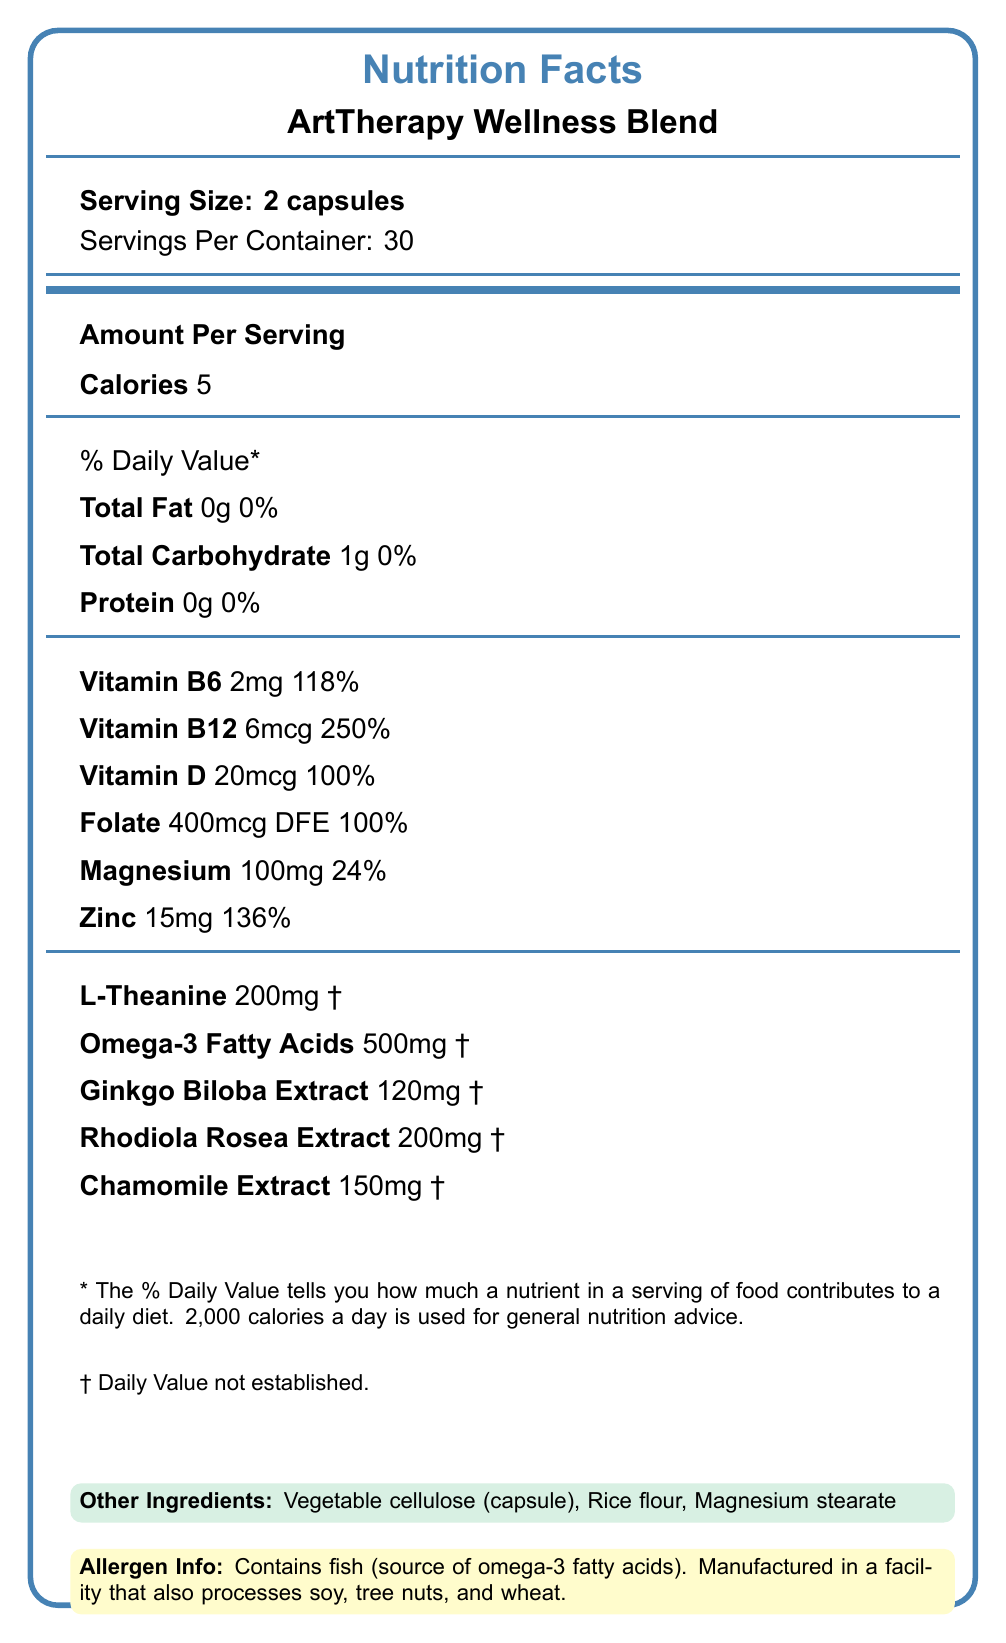what is the serving size of the product? The serving size is clearly mentioned as "Serving Size: 2 capsules" in the document.
Answer: 2 capsules how many servings are there per container? The document states "Servings Per Container: 30".
Answer: 30 what is the calorie content per serving? The document lists the amount per serving, specifying "Calories 5".
Answer: 5 calories what is the amount of Vitamin D per serving? The document specifies "Vitamin D 20mcg".
Answer: 20mcg name two other ingredients included in the capsules. The section labeled "Other Ingredients" includes "Vegetable cellulose (capsule)" and "Rice flour" among others.
Answer: Vegetable cellulose (capsule), Rice flour does this product contain any allergens? According to the document, the product contains fish as an allergen.
Answer: Yes summarize the main benefits of this product. The "Benefits" section lists four key areas where the product claims to offer advantages.
Answer: Supports cognitive function and creativity, promotes relaxation and stress reduction, enhances mood and emotional well-being, aids in focus and concentration during art therapy sessions. what is the amount of Omega-3 Fatty Acids per serving? The document specifies "Omega-3 Fatty Acids 500mg".
Answer: 500mg how much Magnesium is in each serving, and what is its daily value percentage? The document lists "Magnesium 100mg" and "24%" under the "% Daily Value" column.
Answer: 100mg, 24% based on the given information, can you determine if this product is gluten-free? The document does not specify whether the product is gluten-free. It mentions processing in a facility with wheat, which may suggest possible contamination but does not confirm the product's gluten-free status.
Answer: Not enough information what is one potential caution provided about this product? This caution is clearly stated in the document's caution section.
Answer: If you are pregnant, nursing, taking medications, or have a medical condition, consult your healthcare provider before use. what types of activities is this product most beneficial for, according to the benefits section? The benefits section mentions "aids in focus and concentration during art therapy sessions" as one of the key benefits.
Answer: Art therapy sessions are any of the product's claims evaluated by the FDA? The disclaimer in the document states that "These statements have not been evaluated by the Food and Drug Administration".
Answer: No list at least two specific extracts included in the supplement. The document lists "Ginkgo Biloba Extract" and "Rhodiola Rosea Extract" among the ingredients.
Answer: Ginkgo Biloba Extract, Rhodiola Rosea Extract 